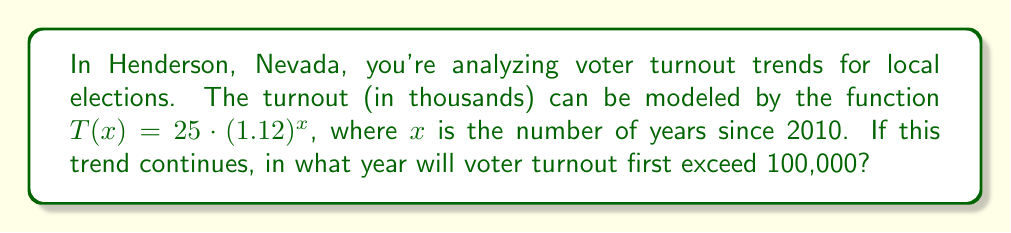Could you help me with this problem? Let's approach this step-by-step:

1) We need to find $x$ when $T(x) > 100$. This is because $T(x)$ is in thousands, so 100,000 voters is represented by 100.

2) Set up the inequality:
   $25 \cdot (1.12)^x > 100$

3) Divide both sides by 25:
   $(1.12)^x > 4$

4) Take the natural log of both sides:
   $x \cdot \ln(1.12) > \ln(4)$

5) Solve for $x$:
   $x > \frac{\ln(4)}{\ln(1.12)} \approx 12.75$

6) Since $x$ represents years since 2010, and we need the first year it exceeds 100,000, we round up to the next whole number: 13.

7) Add 13 to 2010 to get the year:
   $2010 + 13 = 2023$
Answer: 2023 